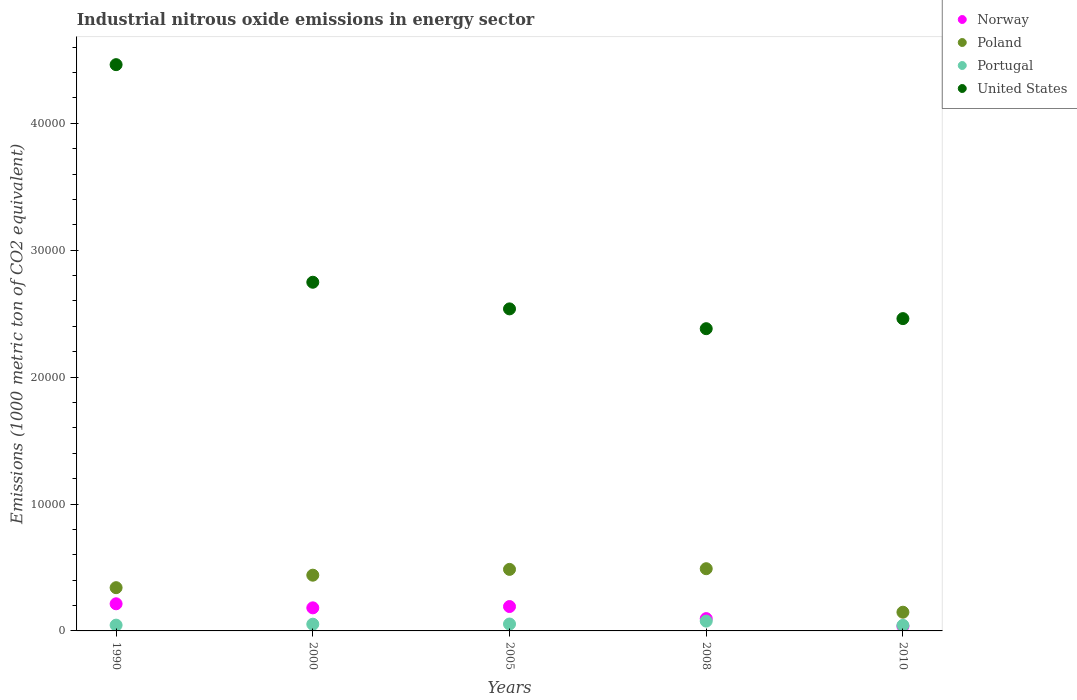Is the number of dotlines equal to the number of legend labels?
Ensure brevity in your answer.  Yes. What is the amount of industrial nitrous oxide emitted in Portugal in 2000?
Keep it short and to the point. 529.5. Across all years, what is the maximum amount of industrial nitrous oxide emitted in Portugal?
Provide a succinct answer. 772.3. Across all years, what is the minimum amount of industrial nitrous oxide emitted in Norway?
Ensure brevity in your answer.  369.3. In which year was the amount of industrial nitrous oxide emitted in Portugal maximum?
Provide a succinct answer. 2008. What is the total amount of industrial nitrous oxide emitted in Poland in the graph?
Your answer should be compact. 1.90e+04. What is the difference between the amount of industrial nitrous oxide emitted in Norway in 2005 and that in 2010?
Your answer should be compact. 1551.9. What is the difference between the amount of industrial nitrous oxide emitted in Poland in 2000 and the amount of industrial nitrous oxide emitted in Portugal in 2010?
Offer a terse response. 3954.1. What is the average amount of industrial nitrous oxide emitted in Norway per year?
Your answer should be very brief. 1443.42. In the year 2010, what is the difference between the amount of industrial nitrous oxide emitted in Poland and amount of industrial nitrous oxide emitted in Norway?
Offer a terse response. 1104.8. What is the ratio of the amount of industrial nitrous oxide emitted in Portugal in 2008 to that in 2010?
Offer a terse response. 1.76. Is the amount of industrial nitrous oxide emitted in Norway in 2005 less than that in 2008?
Offer a very short reply. No. What is the difference between the highest and the second highest amount of industrial nitrous oxide emitted in United States?
Make the answer very short. 1.71e+04. What is the difference between the highest and the lowest amount of industrial nitrous oxide emitted in Poland?
Make the answer very short. 3428.6. In how many years, is the amount of industrial nitrous oxide emitted in United States greater than the average amount of industrial nitrous oxide emitted in United States taken over all years?
Give a very brief answer. 1. Is the sum of the amount of industrial nitrous oxide emitted in Poland in 2008 and 2010 greater than the maximum amount of industrial nitrous oxide emitted in Portugal across all years?
Provide a short and direct response. Yes. Is the amount of industrial nitrous oxide emitted in Poland strictly greater than the amount of industrial nitrous oxide emitted in United States over the years?
Your answer should be very brief. No. How many dotlines are there?
Offer a very short reply. 4. What is the difference between two consecutive major ticks on the Y-axis?
Your answer should be very brief. 10000. Where does the legend appear in the graph?
Your answer should be very brief. Top right. How many legend labels are there?
Provide a succinct answer. 4. How are the legend labels stacked?
Give a very brief answer. Vertical. What is the title of the graph?
Your answer should be very brief. Industrial nitrous oxide emissions in energy sector. Does "Zimbabwe" appear as one of the legend labels in the graph?
Your answer should be very brief. No. What is the label or title of the X-axis?
Offer a very short reply. Years. What is the label or title of the Y-axis?
Offer a terse response. Emissions (1000 metric ton of CO2 equivalent). What is the Emissions (1000 metric ton of CO2 equivalent) of Norway in 1990?
Your response must be concise. 2138. What is the Emissions (1000 metric ton of CO2 equivalent) of Poland in 1990?
Make the answer very short. 3408.2. What is the Emissions (1000 metric ton of CO2 equivalent) in Portugal in 1990?
Provide a succinct answer. 456.2. What is the Emissions (1000 metric ton of CO2 equivalent) of United States in 1990?
Ensure brevity in your answer.  4.46e+04. What is the Emissions (1000 metric ton of CO2 equivalent) in Norway in 2000?
Provide a succinct answer. 1818.2. What is the Emissions (1000 metric ton of CO2 equivalent) of Poland in 2000?
Your answer should be very brief. 4392.5. What is the Emissions (1000 metric ton of CO2 equivalent) of Portugal in 2000?
Your answer should be very brief. 529.5. What is the Emissions (1000 metric ton of CO2 equivalent) of United States in 2000?
Your response must be concise. 2.75e+04. What is the Emissions (1000 metric ton of CO2 equivalent) in Norway in 2005?
Keep it short and to the point. 1921.2. What is the Emissions (1000 metric ton of CO2 equivalent) of Poland in 2005?
Offer a terse response. 4849. What is the Emissions (1000 metric ton of CO2 equivalent) in Portugal in 2005?
Make the answer very short. 543.9. What is the Emissions (1000 metric ton of CO2 equivalent) of United States in 2005?
Provide a succinct answer. 2.54e+04. What is the Emissions (1000 metric ton of CO2 equivalent) in Norway in 2008?
Give a very brief answer. 970.4. What is the Emissions (1000 metric ton of CO2 equivalent) in Poland in 2008?
Your response must be concise. 4902.7. What is the Emissions (1000 metric ton of CO2 equivalent) in Portugal in 2008?
Make the answer very short. 772.3. What is the Emissions (1000 metric ton of CO2 equivalent) of United States in 2008?
Offer a very short reply. 2.38e+04. What is the Emissions (1000 metric ton of CO2 equivalent) in Norway in 2010?
Provide a short and direct response. 369.3. What is the Emissions (1000 metric ton of CO2 equivalent) of Poland in 2010?
Offer a terse response. 1474.1. What is the Emissions (1000 metric ton of CO2 equivalent) in Portugal in 2010?
Offer a very short reply. 438.4. What is the Emissions (1000 metric ton of CO2 equivalent) in United States in 2010?
Give a very brief answer. 2.46e+04. Across all years, what is the maximum Emissions (1000 metric ton of CO2 equivalent) of Norway?
Ensure brevity in your answer.  2138. Across all years, what is the maximum Emissions (1000 metric ton of CO2 equivalent) of Poland?
Make the answer very short. 4902.7. Across all years, what is the maximum Emissions (1000 metric ton of CO2 equivalent) of Portugal?
Provide a short and direct response. 772.3. Across all years, what is the maximum Emissions (1000 metric ton of CO2 equivalent) of United States?
Offer a terse response. 4.46e+04. Across all years, what is the minimum Emissions (1000 metric ton of CO2 equivalent) in Norway?
Provide a short and direct response. 369.3. Across all years, what is the minimum Emissions (1000 metric ton of CO2 equivalent) in Poland?
Ensure brevity in your answer.  1474.1. Across all years, what is the minimum Emissions (1000 metric ton of CO2 equivalent) of Portugal?
Your answer should be compact. 438.4. Across all years, what is the minimum Emissions (1000 metric ton of CO2 equivalent) in United States?
Offer a very short reply. 2.38e+04. What is the total Emissions (1000 metric ton of CO2 equivalent) in Norway in the graph?
Your response must be concise. 7217.1. What is the total Emissions (1000 metric ton of CO2 equivalent) of Poland in the graph?
Your answer should be very brief. 1.90e+04. What is the total Emissions (1000 metric ton of CO2 equivalent) of Portugal in the graph?
Offer a very short reply. 2740.3. What is the total Emissions (1000 metric ton of CO2 equivalent) of United States in the graph?
Your response must be concise. 1.46e+05. What is the difference between the Emissions (1000 metric ton of CO2 equivalent) of Norway in 1990 and that in 2000?
Ensure brevity in your answer.  319.8. What is the difference between the Emissions (1000 metric ton of CO2 equivalent) in Poland in 1990 and that in 2000?
Ensure brevity in your answer.  -984.3. What is the difference between the Emissions (1000 metric ton of CO2 equivalent) of Portugal in 1990 and that in 2000?
Your answer should be very brief. -73.3. What is the difference between the Emissions (1000 metric ton of CO2 equivalent) of United States in 1990 and that in 2000?
Give a very brief answer. 1.71e+04. What is the difference between the Emissions (1000 metric ton of CO2 equivalent) of Norway in 1990 and that in 2005?
Offer a terse response. 216.8. What is the difference between the Emissions (1000 metric ton of CO2 equivalent) in Poland in 1990 and that in 2005?
Your answer should be compact. -1440.8. What is the difference between the Emissions (1000 metric ton of CO2 equivalent) in Portugal in 1990 and that in 2005?
Your answer should be compact. -87.7. What is the difference between the Emissions (1000 metric ton of CO2 equivalent) in United States in 1990 and that in 2005?
Your answer should be very brief. 1.92e+04. What is the difference between the Emissions (1000 metric ton of CO2 equivalent) in Norway in 1990 and that in 2008?
Make the answer very short. 1167.6. What is the difference between the Emissions (1000 metric ton of CO2 equivalent) of Poland in 1990 and that in 2008?
Make the answer very short. -1494.5. What is the difference between the Emissions (1000 metric ton of CO2 equivalent) of Portugal in 1990 and that in 2008?
Provide a succinct answer. -316.1. What is the difference between the Emissions (1000 metric ton of CO2 equivalent) of United States in 1990 and that in 2008?
Make the answer very short. 2.08e+04. What is the difference between the Emissions (1000 metric ton of CO2 equivalent) in Norway in 1990 and that in 2010?
Make the answer very short. 1768.7. What is the difference between the Emissions (1000 metric ton of CO2 equivalent) of Poland in 1990 and that in 2010?
Your answer should be compact. 1934.1. What is the difference between the Emissions (1000 metric ton of CO2 equivalent) of Portugal in 1990 and that in 2010?
Give a very brief answer. 17.8. What is the difference between the Emissions (1000 metric ton of CO2 equivalent) of United States in 1990 and that in 2010?
Your response must be concise. 2.00e+04. What is the difference between the Emissions (1000 metric ton of CO2 equivalent) of Norway in 2000 and that in 2005?
Your response must be concise. -103. What is the difference between the Emissions (1000 metric ton of CO2 equivalent) in Poland in 2000 and that in 2005?
Keep it short and to the point. -456.5. What is the difference between the Emissions (1000 metric ton of CO2 equivalent) of Portugal in 2000 and that in 2005?
Give a very brief answer. -14.4. What is the difference between the Emissions (1000 metric ton of CO2 equivalent) in United States in 2000 and that in 2005?
Offer a very short reply. 2099.2. What is the difference between the Emissions (1000 metric ton of CO2 equivalent) in Norway in 2000 and that in 2008?
Your answer should be compact. 847.8. What is the difference between the Emissions (1000 metric ton of CO2 equivalent) in Poland in 2000 and that in 2008?
Your answer should be very brief. -510.2. What is the difference between the Emissions (1000 metric ton of CO2 equivalent) in Portugal in 2000 and that in 2008?
Offer a terse response. -242.8. What is the difference between the Emissions (1000 metric ton of CO2 equivalent) of United States in 2000 and that in 2008?
Offer a terse response. 3660.1. What is the difference between the Emissions (1000 metric ton of CO2 equivalent) of Norway in 2000 and that in 2010?
Your response must be concise. 1448.9. What is the difference between the Emissions (1000 metric ton of CO2 equivalent) of Poland in 2000 and that in 2010?
Your answer should be compact. 2918.4. What is the difference between the Emissions (1000 metric ton of CO2 equivalent) in Portugal in 2000 and that in 2010?
Give a very brief answer. 91.1. What is the difference between the Emissions (1000 metric ton of CO2 equivalent) in United States in 2000 and that in 2010?
Provide a short and direct response. 2866.4. What is the difference between the Emissions (1000 metric ton of CO2 equivalent) in Norway in 2005 and that in 2008?
Provide a short and direct response. 950.8. What is the difference between the Emissions (1000 metric ton of CO2 equivalent) of Poland in 2005 and that in 2008?
Offer a very short reply. -53.7. What is the difference between the Emissions (1000 metric ton of CO2 equivalent) in Portugal in 2005 and that in 2008?
Your answer should be very brief. -228.4. What is the difference between the Emissions (1000 metric ton of CO2 equivalent) of United States in 2005 and that in 2008?
Your answer should be compact. 1560.9. What is the difference between the Emissions (1000 metric ton of CO2 equivalent) of Norway in 2005 and that in 2010?
Ensure brevity in your answer.  1551.9. What is the difference between the Emissions (1000 metric ton of CO2 equivalent) in Poland in 2005 and that in 2010?
Offer a very short reply. 3374.9. What is the difference between the Emissions (1000 metric ton of CO2 equivalent) in Portugal in 2005 and that in 2010?
Your answer should be very brief. 105.5. What is the difference between the Emissions (1000 metric ton of CO2 equivalent) in United States in 2005 and that in 2010?
Your answer should be very brief. 767.2. What is the difference between the Emissions (1000 metric ton of CO2 equivalent) of Norway in 2008 and that in 2010?
Offer a very short reply. 601.1. What is the difference between the Emissions (1000 metric ton of CO2 equivalent) in Poland in 2008 and that in 2010?
Offer a very short reply. 3428.6. What is the difference between the Emissions (1000 metric ton of CO2 equivalent) of Portugal in 2008 and that in 2010?
Your answer should be compact. 333.9. What is the difference between the Emissions (1000 metric ton of CO2 equivalent) of United States in 2008 and that in 2010?
Offer a terse response. -793.7. What is the difference between the Emissions (1000 metric ton of CO2 equivalent) in Norway in 1990 and the Emissions (1000 metric ton of CO2 equivalent) in Poland in 2000?
Keep it short and to the point. -2254.5. What is the difference between the Emissions (1000 metric ton of CO2 equivalent) of Norway in 1990 and the Emissions (1000 metric ton of CO2 equivalent) of Portugal in 2000?
Ensure brevity in your answer.  1608.5. What is the difference between the Emissions (1000 metric ton of CO2 equivalent) in Norway in 1990 and the Emissions (1000 metric ton of CO2 equivalent) in United States in 2000?
Ensure brevity in your answer.  -2.53e+04. What is the difference between the Emissions (1000 metric ton of CO2 equivalent) of Poland in 1990 and the Emissions (1000 metric ton of CO2 equivalent) of Portugal in 2000?
Provide a succinct answer. 2878.7. What is the difference between the Emissions (1000 metric ton of CO2 equivalent) in Poland in 1990 and the Emissions (1000 metric ton of CO2 equivalent) in United States in 2000?
Provide a short and direct response. -2.41e+04. What is the difference between the Emissions (1000 metric ton of CO2 equivalent) of Portugal in 1990 and the Emissions (1000 metric ton of CO2 equivalent) of United States in 2000?
Keep it short and to the point. -2.70e+04. What is the difference between the Emissions (1000 metric ton of CO2 equivalent) of Norway in 1990 and the Emissions (1000 metric ton of CO2 equivalent) of Poland in 2005?
Offer a very short reply. -2711. What is the difference between the Emissions (1000 metric ton of CO2 equivalent) in Norway in 1990 and the Emissions (1000 metric ton of CO2 equivalent) in Portugal in 2005?
Offer a terse response. 1594.1. What is the difference between the Emissions (1000 metric ton of CO2 equivalent) of Norway in 1990 and the Emissions (1000 metric ton of CO2 equivalent) of United States in 2005?
Provide a succinct answer. -2.32e+04. What is the difference between the Emissions (1000 metric ton of CO2 equivalent) of Poland in 1990 and the Emissions (1000 metric ton of CO2 equivalent) of Portugal in 2005?
Ensure brevity in your answer.  2864.3. What is the difference between the Emissions (1000 metric ton of CO2 equivalent) of Poland in 1990 and the Emissions (1000 metric ton of CO2 equivalent) of United States in 2005?
Give a very brief answer. -2.20e+04. What is the difference between the Emissions (1000 metric ton of CO2 equivalent) of Portugal in 1990 and the Emissions (1000 metric ton of CO2 equivalent) of United States in 2005?
Your answer should be very brief. -2.49e+04. What is the difference between the Emissions (1000 metric ton of CO2 equivalent) of Norway in 1990 and the Emissions (1000 metric ton of CO2 equivalent) of Poland in 2008?
Your answer should be compact. -2764.7. What is the difference between the Emissions (1000 metric ton of CO2 equivalent) of Norway in 1990 and the Emissions (1000 metric ton of CO2 equivalent) of Portugal in 2008?
Offer a very short reply. 1365.7. What is the difference between the Emissions (1000 metric ton of CO2 equivalent) in Norway in 1990 and the Emissions (1000 metric ton of CO2 equivalent) in United States in 2008?
Your answer should be very brief. -2.17e+04. What is the difference between the Emissions (1000 metric ton of CO2 equivalent) in Poland in 1990 and the Emissions (1000 metric ton of CO2 equivalent) in Portugal in 2008?
Give a very brief answer. 2635.9. What is the difference between the Emissions (1000 metric ton of CO2 equivalent) of Poland in 1990 and the Emissions (1000 metric ton of CO2 equivalent) of United States in 2008?
Keep it short and to the point. -2.04e+04. What is the difference between the Emissions (1000 metric ton of CO2 equivalent) in Portugal in 1990 and the Emissions (1000 metric ton of CO2 equivalent) in United States in 2008?
Give a very brief answer. -2.34e+04. What is the difference between the Emissions (1000 metric ton of CO2 equivalent) in Norway in 1990 and the Emissions (1000 metric ton of CO2 equivalent) in Poland in 2010?
Give a very brief answer. 663.9. What is the difference between the Emissions (1000 metric ton of CO2 equivalent) of Norway in 1990 and the Emissions (1000 metric ton of CO2 equivalent) of Portugal in 2010?
Make the answer very short. 1699.6. What is the difference between the Emissions (1000 metric ton of CO2 equivalent) of Norway in 1990 and the Emissions (1000 metric ton of CO2 equivalent) of United States in 2010?
Make the answer very short. -2.25e+04. What is the difference between the Emissions (1000 metric ton of CO2 equivalent) of Poland in 1990 and the Emissions (1000 metric ton of CO2 equivalent) of Portugal in 2010?
Offer a very short reply. 2969.8. What is the difference between the Emissions (1000 metric ton of CO2 equivalent) in Poland in 1990 and the Emissions (1000 metric ton of CO2 equivalent) in United States in 2010?
Give a very brief answer. -2.12e+04. What is the difference between the Emissions (1000 metric ton of CO2 equivalent) in Portugal in 1990 and the Emissions (1000 metric ton of CO2 equivalent) in United States in 2010?
Your response must be concise. -2.42e+04. What is the difference between the Emissions (1000 metric ton of CO2 equivalent) of Norway in 2000 and the Emissions (1000 metric ton of CO2 equivalent) of Poland in 2005?
Provide a succinct answer. -3030.8. What is the difference between the Emissions (1000 metric ton of CO2 equivalent) in Norway in 2000 and the Emissions (1000 metric ton of CO2 equivalent) in Portugal in 2005?
Make the answer very short. 1274.3. What is the difference between the Emissions (1000 metric ton of CO2 equivalent) in Norway in 2000 and the Emissions (1000 metric ton of CO2 equivalent) in United States in 2005?
Offer a very short reply. -2.36e+04. What is the difference between the Emissions (1000 metric ton of CO2 equivalent) of Poland in 2000 and the Emissions (1000 metric ton of CO2 equivalent) of Portugal in 2005?
Give a very brief answer. 3848.6. What is the difference between the Emissions (1000 metric ton of CO2 equivalent) in Poland in 2000 and the Emissions (1000 metric ton of CO2 equivalent) in United States in 2005?
Your response must be concise. -2.10e+04. What is the difference between the Emissions (1000 metric ton of CO2 equivalent) in Portugal in 2000 and the Emissions (1000 metric ton of CO2 equivalent) in United States in 2005?
Your response must be concise. -2.48e+04. What is the difference between the Emissions (1000 metric ton of CO2 equivalent) of Norway in 2000 and the Emissions (1000 metric ton of CO2 equivalent) of Poland in 2008?
Your answer should be very brief. -3084.5. What is the difference between the Emissions (1000 metric ton of CO2 equivalent) in Norway in 2000 and the Emissions (1000 metric ton of CO2 equivalent) in Portugal in 2008?
Your answer should be very brief. 1045.9. What is the difference between the Emissions (1000 metric ton of CO2 equivalent) in Norway in 2000 and the Emissions (1000 metric ton of CO2 equivalent) in United States in 2008?
Offer a very short reply. -2.20e+04. What is the difference between the Emissions (1000 metric ton of CO2 equivalent) in Poland in 2000 and the Emissions (1000 metric ton of CO2 equivalent) in Portugal in 2008?
Provide a short and direct response. 3620.2. What is the difference between the Emissions (1000 metric ton of CO2 equivalent) of Poland in 2000 and the Emissions (1000 metric ton of CO2 equivalent) of United States in 2008?
Keep it short and to the point. -1.94e+04. What is the difference between the Emissions (1000 metric ton of CO2 equivalent) of Portugal in 2000 and the Emissions (1000 metric ton of CO2 equivalent) of United States in 2008?
Your answer should be very brief. -2.33e+04. What is the difference between the Emissions (1000 metric ton of CO2 equivalent) of Norway in 2000 and the Emissions (1000 metric ton of CO2 equivalent) of Poland in 2010?
Provide a succinct answer. 344.1. What is the difference between the Emissions (1000 metric ton of CO2 equivalent) of Norway in 2000 and the Emissions (1000 metric ton of CO2 equivalent) of Portugal in 2010?
Keep it short and to the point. 1379.8. What is the difference between the Emissions (1000 metric ton of CO2 equivalent) of Norway in 2000 and the Emissions (1000 metric ton of CO2 equivalent) of United States in 2010?
Give a very brief answer. -2.28e+04. What is the difference between the Emissions (1000 metric ton of CO2 equivalent) in Poland in 2000 and the Emissions (1000 metric ton of CO2 equivalent) in Portugal in 2010?
Your answer should be compact. 3954.1. What is the difference between the Emissions (1000 metric ton of CO2 equivalent) in Poland in 2000 and the Emissions (1000 metric ton of CO2 equivalent) in United States in 2010?
Your answer should be very brief. -2.02e+04. What is the difference between the Emissions (1000 metric ton of CO2 equivalent) in Portugal in 2000 and the Emissions (1000 metric ton of CO2 equivalent) in United States in 2010?
Keep it short and to the point. -2.41e+04. What is the difference between the Emissions (1000 metric ton of CO2 equivalent) of Norway in 2005 and the Emissions (1000 metric ton of CO2 equivalent) of Poland in 2008?
Ensure brevity in your answer.  -2981.5. What is the difference between the Emissions (1000 metric ton of CO2 equivalent) of Norway in 2005 and the Emissions (1000 metric ton of CO2 equivalent) of Portugal in 2008?
Provide a short and direct response. 1148.9. What is the difference between the Emissions (1000 metric ton of CO2 equivalent) in Norway in 2005 and the Emissions (1000 metric ton of CO2 equivalent) in United States in 2008?
Provide a succinct answer. -2.19e+04. What is the difference between the Emissions (1000 metric ton of CO2 equivalent) of Poland in 2005 and the Emissions (1000 metric ton of CO2 equivalent) of Portugal in 2008?
Offer a very short reply. 4076.7. What is the difference between the Emissions (1000 metric ton of CO2 equivalent) in Poland in 2005 and the Emissions (1000 metric ton of CO2 equivalent) in United States in 2008?
Your answer should be compact. -1.90e+04. What is the difference between the Emissions (1000 metric ton of CO2 equivalent) of Portugal in 2005 and the Emissions (1000 metric ton of CO2 equivalent) of United States in 2008?
Provide a succinct answer. -2.33e+04. What is the difference between the Emissions (1000 metric ton of CO2 equivalent) in Norway in 2005 and the Emissions (1000 metric ton of CO2 equivalent) in Poland in 2010?
Your response must be concise. 447.1. What is the difference between the Emissions (1000 metric ton of CO2 equivalent) of Norway in 2005 and the Emissions (1000 metric ton of CO2 equivalent) of Portugal in 2010?
Provide a short and direct response. 1482.8. What is the difference between the Emissions (1000 metric ton of CO2 equivalent) in Norway in 2005 and the Emissions (1000 metric ton of CO2 equivalent) in United States in 2010?
Keep it short and to the point. -2.27e+04. What is the difference between the Emissions (1000 metric ton of CO2 equivalent) in Poland in 2005 and the Emissions (1000 metric ton of CO2 equivalent) in Portugal in 2010?
Ensure brevity in your answer.  4410.6. What is the difference between the Emissions (1000 metric ton of CO2 equivalent) in Poland in 2005 and the Emissions (1000 metric ton of CO2 equivalent) in United States in 2010?
Keep it short and to the point. -1.98e+04. What is the difference between the Emissions (1000 metric ton of CO2 equivalent) in Portugal in 2005 and the Emissions (1000 metric ton of CO2 equivalent) in United States in 2010?
Provide a short and direct response. -2.41e+04. What is the difference between the Emissions (1000 metric ton of CO2 equivalent) in Norway in 2008 and the Emissions (1000 metric ton of CO2 equivalent) in Poland in 2010?
Provide a short and direct response. -503.7. What is the difference between the Emissions (1000 metric ton of CO2 equivalent) of Norway in 2008 and the Emissions (1000 metric ton of CO2 equivalent) of Portugal in 2010?
Your response must be concise. 532. What is the difference between the Emissions (1000 metric ton of CO2 equivalent) in Norway in 2008 and the Emissions (1000 metric ton of CO2 equivalent) in United States in 2010?
Your answer should be very brief. -2.36e+04. What is the difference between the Emissions (1000 metric ton of CO2 equivalent) in Poland in 2008 and the Emissions (1000 metric ton of CO2 equivalent) in Portugal in 2010?
Offer a very short reply. 4464.3. What is the difference between the Emissions (1000 metric ton of CO2 equivalent) of Poland in 2008 and the Emissions (1000 metric ton of CO2 equivalent) of United States in 2010?
Offer a very short reply. -1.97e+04. What is the difference between the Emissions (1000 metric ton of CO2 equivalent) in Portugal in 2008 and the Emissions (1000 metric ton of CO2 equivalent) in United States in 2010?
Provide a succinct answer. -2.38e+04. What is the average Emissions (1000 metric ton of CO2 equivalent) in Norway per year?
Offer a very short reply. 1443.42. What is the average Emissions (1000 metric ton of CO2 equivalent) in Poland per year?
Offer a very short reply. 3805.3. What is the average Emissions (1000 metric ton of CO2 equivalent) of Portugal per year?
Your response must be concise. 548.06. What is the average Emissions (1000 metric ton of CO2 equivalent) of United States per year?
Give a very brief answer. 2.92e+04. In the year 1990, what is the difference between the Emissions (1000 metric ton of CO2 equivalent) in Norway and Emissions (1000 metric ton of CO2 equivalent) in Poland?
Your response must be concise. -1270.2. In the year 1990, what is the difference between the Emissions (1000 metric ton of CO2 equivalent) in Norway and Emissions (1000 metric ton of CO2 equivalent) in Portugal?
Provide a short and direct response. 1681.8. In the year 1990, what is the difference between the Emissions (1000 metric ton of CO2 equivalent) of Norway and Emissions (1000 metric ton of CO2 equivalent) of United States?
Keep it short and to the point. -4.25e+04. In the year 1990, what is the difference between the Emissions (1000 metric ton of CO2 equivalent) of Poland and Emissions (1000 metric ton of CO2 equivalent) of Portugal?
Make the answer very short. 2952. In the year 1990, what is the difference between the Emissions (1000 metric ton of CO2 equivalent) of Poland and Emissions (1000 metric ton of CO2 equivalent) of United States?
Provide a succinct answer. -4.12e+04. In the year 1990, what is the difference between the Emissions (1000 metric ton of CO2 equivalent) of Portugal and Emissions (1000 metric ton of CO2 equivalent) of United States?
Your answer should be compact. -4.42e+04. In the year 2000, what is the difference between the Emissions (1000 metric ton of CO2 equivalent) of Norway and Emissions (1000 metric ton of CO2 equivalent) of Poland?
Keep it short and to the point. -2574.3. In the year 2000, what is the difference between the Emissions (1000 metric ton of CO2 equivalent) in Norway and Emissions (1000 metric ton of CO2 equivalent) in Portugal?
Keep it short and to the point. 1288.7. In the year 2000, what is the difference between the Emissions (1000 metric ton of CO2 equivalent) of Norway and Emissions (1000 metric ton of CO2 equivalent) of United States?
Your response must be concise. -2.57e+04. In the year 2000, what is the difference between the Emissions (1000 metric ton of CO2 equivalent) of Poland and Emissions (1000 metric ton of CO2 equivalent) of Portugal?
Your response must be concise. 3863. In the year 2000, what is the difference between the Emissions (1000 metric ton of CO2 equivalent) of Poland and Emissions (1000 metric ton of CO2 equivalent) of United States?
Ensure brevity in your answer.  -2.31e+04. In the year 2000, what is the difference between the Emissions (1000 metric ton of CO2 equivalent) of Portugal and Emissions (1000 metric ton of CO2 equivalent) of United States?
Make the answer very short. -2.69e+04. In the year 2005, what is the difference between the Emissions (1000 metric ton of CO2 equivalent) in Norway and Emissions (1000 metric ton of CO2 equivalent) in Poland?
Offer a very short reply. -2927.8. In the year 2005, what is the difference between the Emissions (1000 metric ton of CO2 equivalent) of Norway and Emissions (1000 metric ton of CO2 equivalent) of Portugal?
Make the answer very short. 1377.3. In the year 2005, what is the difference between the Emissions (1000 metric ton of CO2 equivalent) of Norway and Emissions (1000 metric ton of CO2 equivalent) of United States?
Make the answer very short. -2.35e+04. In the year 2005, what is the difference between the Emissions (1000 metric ton of CO2 equivalent) in Poland and Emissions (1000 metric ton of CO2 equivalent) in Portugal?
Provide a short and direct response. 4305.1. In the year 2005, what is the difference between the Emissions (1000 metric ton of CO2 equivalent) of Poland and Emissions (1000 metric ton of CO2 equivalent) of United States?
Your answer should be compact. -2.05e+04. In the year 2005, what is the difference between the Emissions (1000 metric ton of CO2 equivalent) of Portugal and Emissions (1000 metric ton of CO2 equivalent) of United States?
Your answer should be compact. -2.48e+04. In the year 2008, what is the difference between the Emissions (1000 metric ton of CO2 equivalent) in Norway and Emissions (1000 metric ton of CO2 equivalent) in Poland?
Provide a short and direct response. -3932.3. In the year 2008, what is the difference between the Emissions (1000 metric ton of CO2 equivalent) of Norway and Emissions (1000 metric ton of CO2 equivalent) of Portugal?
Give a very brief answer. 198.1. In the year 2008, what is the difference between the Emissions (1000 metric ton of CO2 equivalent) in Norway and Emissions (1000 metric ton of CO2 equivalent) in United States?
Your answer should be compact. -2.28e+04. In the year 2008, what is the difference between the Emissions (1000 metric ton of CO2 equivalent) of Poland and Emissions (1000 metric ton of CO2 equivalent) of Portugal?
Make the answer very short. 4130.4. In the year 2008, what is the difference between the Emissions (1000 metric ton of CO2 equivalent) in Poland and Emissions (1000 metric ton of CO2 equivalent) in United States?
Give a very brief answer. -1.89e+04. In the year 2008, what is the difference between the Emissions (1000 metric ton of CO2 equivalent) of Portugal and Emissions (1000 metric ton of CO2 equivalent) of United States?
Ensure brevity in your answer.  -2.30e+04. In the year 2010, what is the difference between the Emissions (1000 metric ton of CO2 equivalent) of Norway and Emissions (1000 metric ton of CO2 equivalent) of Poland?
Provide a succinct answer. -1104.8. In the year 2010, what is the difference between the Emissions (1000 metric ton of CO2 equivalent) in Norway and Emissions (1000 metric ton of CO2 equivalent) in Portugal?
Your answer should be compact. -69.1. In the year 2010, what is the difference between the Emissions (1000 metric ton of CO2 equivalent) in Norway and Emissions (1000 metric ton of CO2 equivalent) in United States?
Your answer should be very brief. -2.42e+04. In the year 2010, what is the difference between the Emissions (1000 metric ton of CO2 equivalent) in Poland and Emissions (1000 metric ton of CO2 equivalent) in Portugal?
Ensure brevity in your answer.  1035.7. In the year 2010, what is the difference between the Emissions (1000 metric ton of CO2 equivalent) in Poland and Emissions (1000 metric ton of CO2 equivalent) in United States?
Your answer should be very brief. -2.31e+04. In the year 2010, what is the difference between the Emissions (1000 metric ton of CO2 equivalent) in Portugal and Emissions (1000 metric ton of CO2 equivalent) in United States?
Your answer should be compact. -2.42e+04. What is the ratio of the Emissions (1000 metric ton of CO2 equivalent) of Norway in 1990 to that in 2000?
Ensure brevity in your answer.  1.18. What is the ratio of the Emissions (1000 metric ton of CO2 equivalent) in Poland in 1990 to that in 2000?
Provide a succinct answer. 0.78. What is the ratio of the Emissions (1000 metric ton of CO2 equivalent) in Portugal in 1990 to that in 2000?
Provide a short and direct response. 0.86. What is the ratio of the Emissions (1000 metric ton of CO2 equivalent) of United States in 1990 to that in 2000?
Your answer should be very brief. 1.62. What is the ratio of the Emissions (1000 metric ton of CO2 equivalent) in Norway in 1990 to that in 2005?
Your answer should be compact. 1.11. What is the ratio of the Emissions (1000 metric ton of CO2 equivalent) in Poland in 1990 to that in 2005?
Offer a terse response. 0.7. What is the ratio of the Emissions (1000 metric ton of CO2 equivalent) in Portugal in 1990 to that in 2005?
Your response must be concise. 0.84. What is the ratio of the Emissions (1000 metric ton of CO2 equivalent) in United States in 1990 to that in 2005?
Keep it short and to the point. 1.76. What is the ratio of the Emissions (1000 metric ton of CO2 equivalent) in Norway in 1990 to that in 2008?
Provide a short and direct response. 2.2. What is the ratio of the Emissions (1000 metric ton of CO2 equivalent) of Poland in 1990 to that in 2008?
Keep it short and to the point. 0.7. What is the ratio of the Emissions (1000 metric ton of CO2 equivalent) in Portugal in 1990 to that in 2008?
Keep it short and to the point. 0.59. What is the ratio of the Emissions (1000 metric ton of CO2 equivalent) of United States in 1990 to that in 2008?
Make the answer very short. 1.87. What is the ratio of the Emissions (1000 metric ton of CO2 equivalent) of Norway in 1990 to that in 2010?
Offer a very short reply. 5.79. What is the ratio of the Emissions (1000 metric ton of CO2 equivalent) of Poland in 1990 to that in 2010?
Offer a very short reply. 2.31. What is the ratio of the Emissions (1000 metric ton of CO2 equivalent) in Portugal in 1990 to that in 2010?
Your answer should be compact. 1.04. What is the ratio of the Emissions (1000 metric ton of CO2 equivalent) of United States in 1990 to that in 2010?
Provide a succinct answer. 1.81. What is the ratio of the Emissions (1000 metric ton of CO2 equivalent) of Norway in 2000 to that in 2005?
Your answer should be compact. 0.95. What is the ratio of the Emissions (1000 metric ton of CO2 equivalent) in Poland in 2000 to that in 2005?
Ensure brevity in your answer.  0.91. What is the ratio of the Emissions (1000 metric ton of CO2 equivalent) of Portugal in 2000 to that in 2005?
Offer a terse response. 0.97. What is the ratio of the Emissions (1000 metric ton of CO2 equivalent) in United States in 2000 to that in 2005?
Your answer should be compact. 1.08. What is the ratio of the Emissions (1000 metric ton of CO2 equivalent) in Norway in 2000 to that in 2008?
Your answer should be compact. 1.87. What is the ratio of the Emissions (1000 metric ton of CO2 equivalent) of Poland in 2000 to that in 2008?
Offer a very short reply. 0.9. What is the ratio of the Emissions (1000 metric ton of CO2 equivalent) in Portugal in 2000 to that in 2008?
Offer a terse response. 0.69. What is the ratio of the Emissions (1000 metric ton of CO2 equivalent) in United States in 2000 to that in 2008?
Provide a succinct answer. 1.15. What is the ratio of the Emissions (1000 metric ton of CO2 equivalent) of Norway in 2000 to that in 2010?
Make the answer very short. 4.92. What is the ratio of the Emissions (1000 metric ton of CO2 equivalent) of Poland in 2000 to that in 2010?
Provide a short and direct response. 2.98. What is the ratio of the Emissions (1000 metric ton of CO2 equivalent) of Portugal in 2000 to that in 2010?
Provide a succinct answer. 1.21. What is the ratio of the Emissions (1000 metric ton of CO2 equivalent) of United States in 2000 to that in 2010?
Provide a short and direct response. 1.12. What is the ratio of the Emissions (1000 metric ton of CO2 equivalent) of Norway in 2005 to that in 2008?
Keep it short and to the point. 1.98. What is the ratio of the Emissions (1000 metric ton of CO2 equivalent) in Portugal in 2005 to that in 2008?
Provide a short and direct response. 0.7. What is the ratio of the Emissions (1000 metric ton of CO2 equivalent) in United States in 2005 to that in 2008?
Your answer should be very brief. 1.07. What is the ratio of the Emissions (1000 metric ton of CO2 equivalent) of Norway in 2005 to that in 2010?
Your answer should be compact. 5.2. What is the ratio of the Emissions (1000 metric ton of CO2 equivalent) in Poland in 2005 to that in 2010?
Keep it short and to the point. 3.29. What is the ratio of the Emissions (1000 metric ton of CO2 equivalent) of Portugal in 2005 to that in 2010?
Give a very brief answer. 1.24. What is the ratio of the Emissions (1000 metric ton of CO2 equivalent) in United States in 2005 to that in 2010?
Your response must be concise. 1.03. What is the ratio of the Emissions (1000 metric ton of CO2 equivalent) of Norway in 2008 to that in 2010?
Your answer should be very brief. 2.63. What is the ratio of the Emissions (1000 metric ton of CO2 equivalent) in Poland in 2008 to that in 2010?
Ensure brevity in your answer.  3.33. What is the ratio of the Emissions (1000 metric ton of CO2 equivalent) of Portugal in 2008 to that in 2010?
Offer a very short reply. 1.76. What is the ratio of the Emissions (1000 metric ton of CO2 equivalent) in United States in 2008 to that in 2010?
Your response must be concise. 0.97. What is the difference between the highest and the second highest Emissions (1000 metric ton of CO2 equivalent) of Norway?
Offer a terse response. 216.8. What is the difference between the highest and the second highest Emissions (1000 metric ton of CO2 equivalent) in Poland?
Your response must be concise. 53.7. What is the difference between the highest and the second highest Emissions (1000 metric ton of CO2 equivalent) of Portugal?
Offer a terse response. 228.4. What is the difference between the highest and the second highest Emissions (1000 metric ton of CO2 equivalent) in United States?
Your answer should be compact. 1.71e+04. What is the difference between the highest and the lowest Emissions (1000 metric ton of CO2 equivalent) in Norway?
Keep it short and to the point. 1768.7. What is the difference between the highest and the lowest Emissions (1000 metric ton of CO2 equivalent) in Poland?
Ensure brevity in your answer.  3428.6. What is the difference between the highest and the lowest Emissions (1000 metric ton of CO2 equivalent) in Portugal?
Keep it short and to the point. 333.9. What is the difference between the highest and the lowest Emissions (1000 metric ton of CO2 equivalent) in United States?
Provide a short and direct response. 2.08e+04. 